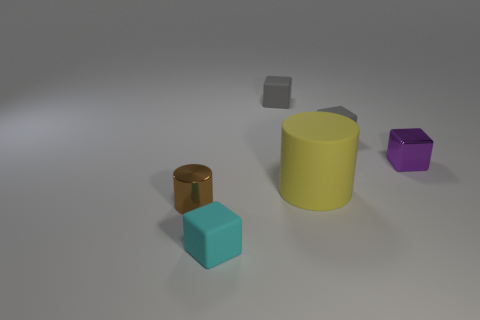Are there any other things that are the same size as the yellow matte cylinder?
Offer a terse response. No. There is a small metallic object in front of the small shiny block; what number of gray rubber objects are in front of it?
Give a very brief answer. 0. What material is the cyan thing that is the same size as the brown object?
Provide a short and direct response. Rubber. What shape is the big matte object to the right of the metallic object on the left side of the matte block that is in front of the tiny purple shiny cube?
Provide a short and direct response. Cylinder. What is the shape of the metal thing that is the same size as the purple metallic cube?
Offer a very short reply. Cylinder. There is a yellow matte cylinder that is behind the cylinder to the left of the tiny cyan rubber thing; how many tiny cyan cubes are left of it?
Your answer should be very brief. 1. Are there more tiny cyan objects that are in front of the rubber cylinder than tiny brown metal cylinders that are on the right side of the small cyan cube?
Ensure brevity in your answer.  Yes. How many other matte objects have the same shape as the brown object?
Give a very brief answer. 1. How many things are either rubber cubes that are behind the small cyan rubber thing or small blocks behind the small brown metal cylinder?
Your answer should be compact. 3. There is a small thing that is to the left of the small rubber cube in front of the metallic object to the left of the purple metallic thing; what is it made of?
Ensure brevity in your answer.  Metal. 